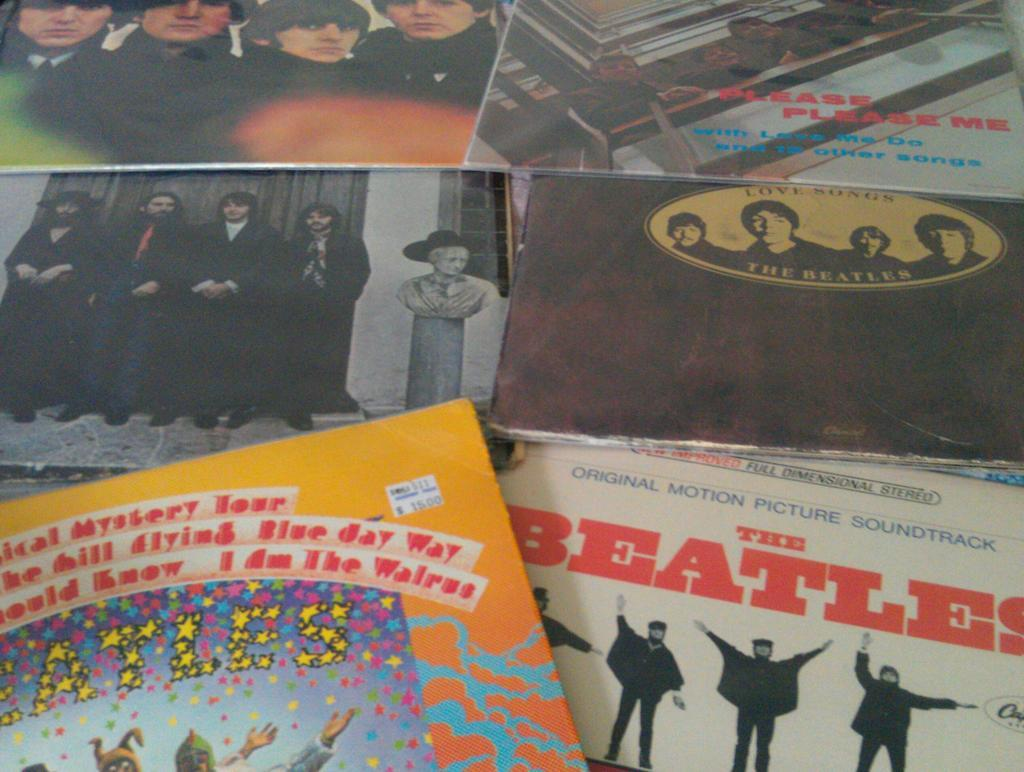<image>
Write a terse but informative summary of the picture. The beatles record and love songs by the beatles. 